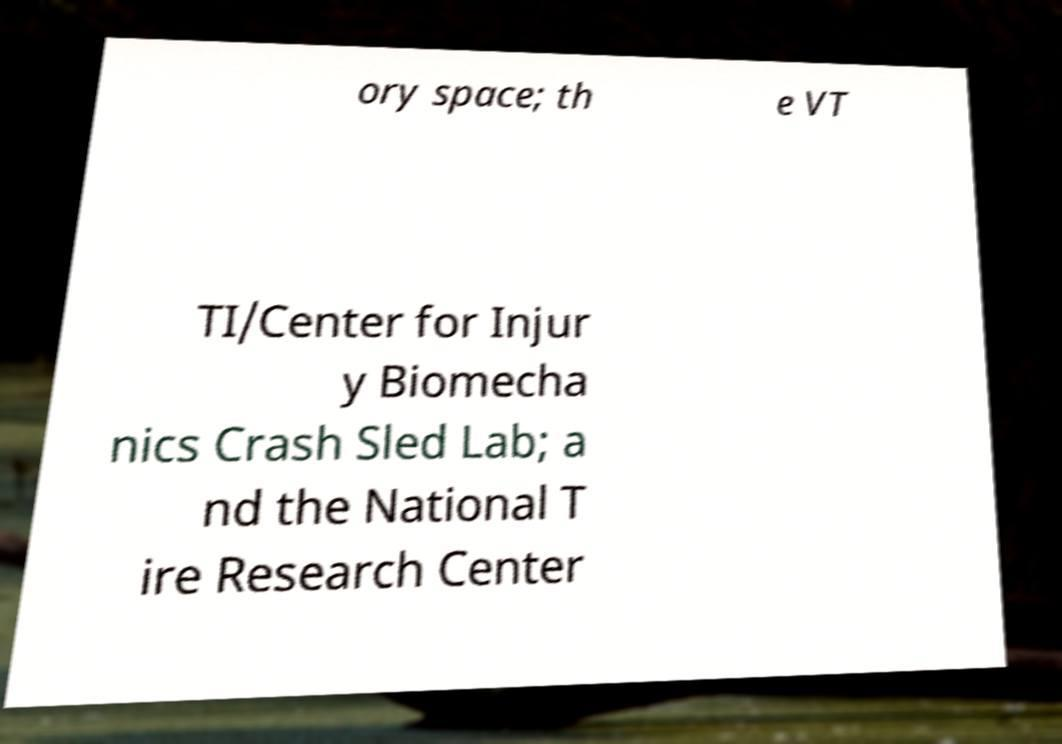What messages or text are displayed in this image? I need them in a readable, typed format. ory space; th e VT TI/Center for Injur y Biomecha nics Crash Sled Lab; a nd the National T ire Research Center 